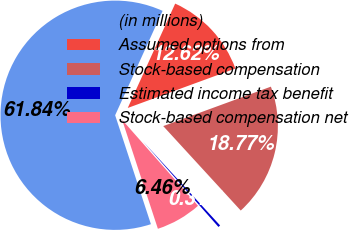Convert chart. <chart><loc_0><loc_0><loc_500><loc_500><pie_chart><fcel>(in millions)<fcel>Assumed options from<fcel>Stock-based compensation<fcel>Estimated income tax benefit<fcel>Stock-based compensation net<nl><fcel>61.84%<fcel>12.62%<fcel>18.77%<fcel>0.31%<fcel>6.46%<nl></chart> 